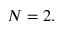Convert formula to latex. <formula><loc_0><loc_0><loc_500><loc_500>N = 2 .</formula> 